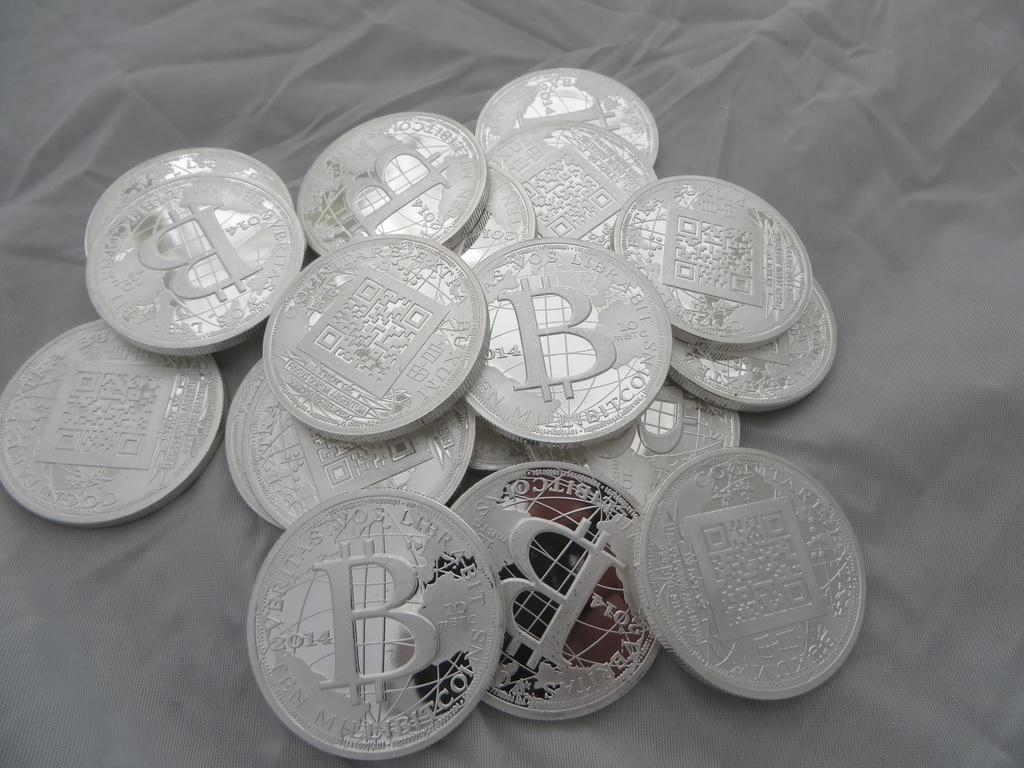<image>
Relay a brief, clear account of the picture shown. Bunch of silver coins on a table with the letter B on it. 